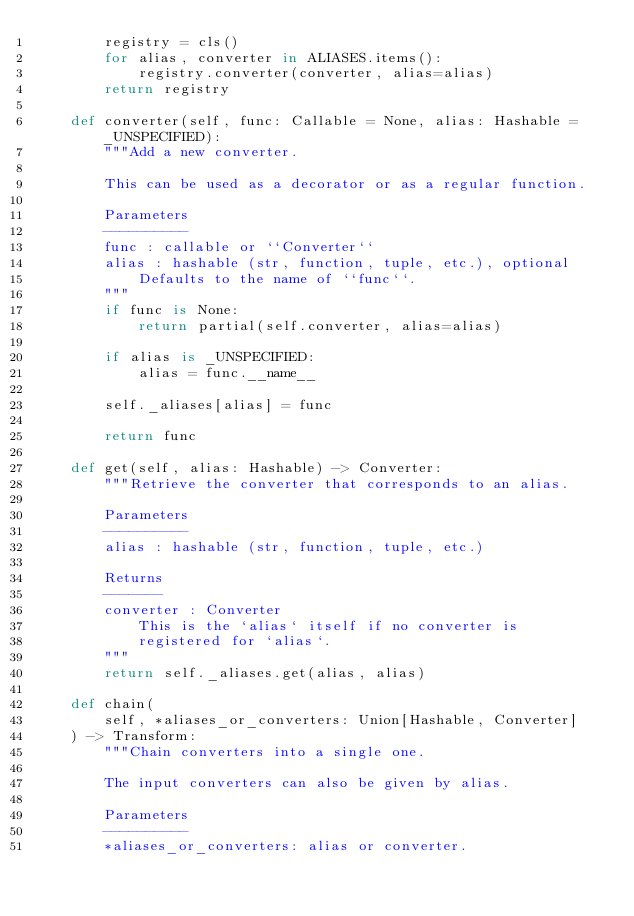Convert code to text. <code><loc_0><loc_0><loc_500><loc_500><_Python_>        registry = cls()
        for alias, converter in ALIASES.items():
            registry.converter(converter, alias=alias)
        return registry

    def converter(self, func: Callable = None, alias: Hashable = _UNSPECIFIED):
        """Add a new converter.

        This can be used as a decorator or as a regular function.

        Parameters
        ----------
        func : callable or ``Converter``
        alias : hashable (str, function, tuple, etc.), optional
            Defaults to the name of ``func``.
        """
        if func is None:
            return partial(self.converter, alias=alias)

        if alias is _UNSPECIFIED:
            alias = func.__name__

        self._aliases[alias] = func

        return func

    def get(self, alias: Hashable) -> Converter:
        """Retrieve the converter that corresponds to an alias.

        Parameters
        ----------
        alias : hashable (str, function, tuple, etc.)

        Returns
        -------
        converter : Converter
            This is the `alias` itself if no converter is
            registered for `alias`.
        """
        return self._aliases.get(alias, alias)

    def chain(
        self, *aliases_or_converters: Union[Hashable, Converter]
    ) -> Transform:
        """Chain converters into a single one.

        The input converters can also be given by alias.

        Parameters
        ----------
        *aliases_or_converters: alias or converter.
</code> 